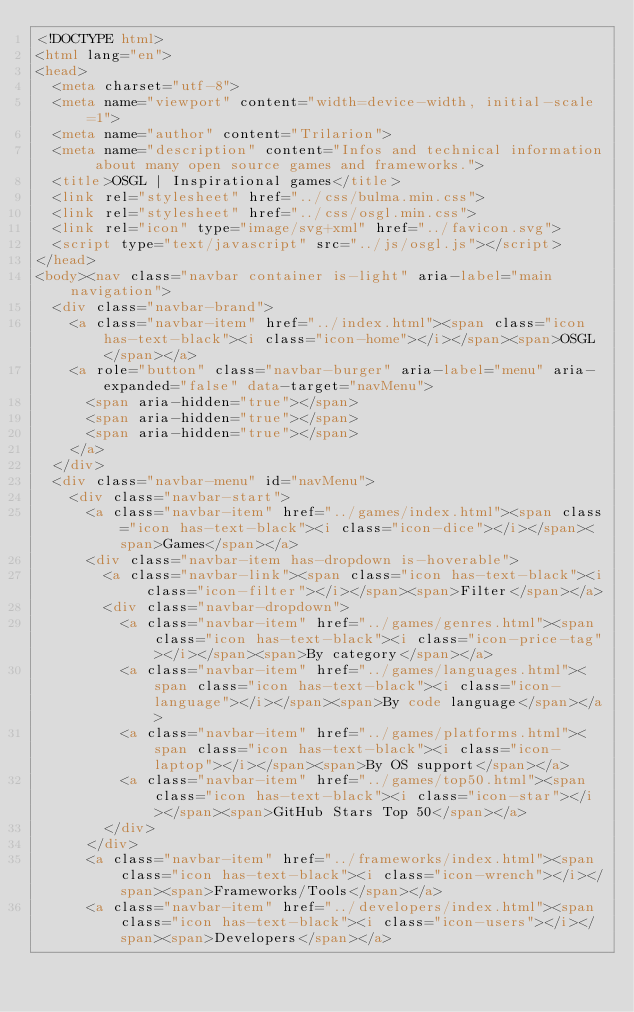<code> <loc_0><loc_0><loc_500><loc_500><_HTML_><!DOCTYPE html>
<html lang="en">
<head>
  <meta charset="utf-8">
  <meta name="viewport" content="width=device-width, initial-scale=1">
  <meta name="author" content="Trilarion">
  <meta name="description" content="Infos and technical information about many open source games and frameworks.">
  <title>OSGL | Inspirational games</title>
  <link rel="stylesheet" href="../css/bulma.min.css">
  <link rel="stylesheet" href="../css/osgl.min.css">
  <link rel="icon" type="image/svg+xml" href="../favicon.svg">
  <script type="text/javascript" src="../js/osgl.js"></script>
</head>
<body><nav class="navbar container is-light" aria-label="main navigation">
  <div class="navbar-brand">
    <a class="navbar-item" href="../index.html"><span class="icon has-text-black"><i class="icon-home"></i></span><span>OSGL</span></a>
    <a role="button" class="navbar-burger" aria-label="menu" aria-expanded="false" data-target="navMenu">
      <span aria-hidden="true"></span>
      <span aria-hidden="true"></span>
      <span aria-hidden="true"></span>
    </a>
  </div>
  <div class="navbar-menu" id="navMenu">
    <div class="navbar-start">
      <a class="navbar-item" href="../games/index.html"><span class="icon has-text-black"><i class="icon-dice"></i></span><span>Games</span></a>
      <div class="navbar-item has-dropdown is-hoverable">
        <a class="navbar-link"><span class="icon has-text-black"><i class="icon-filter"></i></span><span>Filter</span></a>
        <div class="navbar-dropdown">
          <a class="navbar-item" href="../games/genres.html"><span class="icon has-text-black"><i class="icon-price-tag"></i></span><span>By category</span></a>
          <a class="navbar-item" href="../games/languages.html"><span class="icon has-text-black"><i class="icon-language"></i></span><span>By code language</span></a>
          <a class="navbar-item" href="../games/platforms.html"><span class="icon has-text-black"><i class="icon-laptop"></i></span><span>By OS support</span></a>
          <a class="navbar-item" href="../games/top50.html"><span class="icon has-text-black"><i class="icon-star"></i></span><span>GitHub Stars Top 50</span></a>
        </div>
      </div>
      <a class="navbar-item" href="../frameworks/index.html"><span class="icon has-text-black"><i class="icon-wrench"></i></span><span>Frameworks/Tools</span></a>
      <a class="navbar-item" href="../developers/index.html"><span class="icon has-text-black"><i class="icon-users"></i></span><span>Developers</span></a></code> 